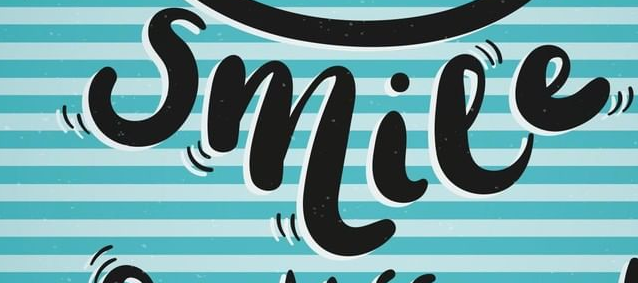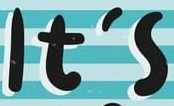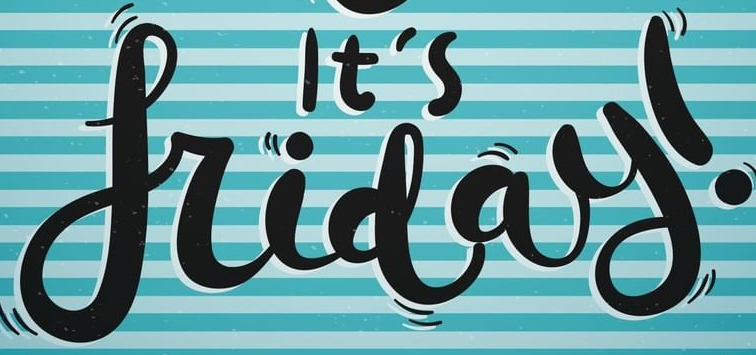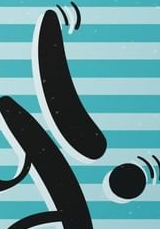What text appears in these images from left to right, separated by a semicolon? smile; It's; friday; ! 